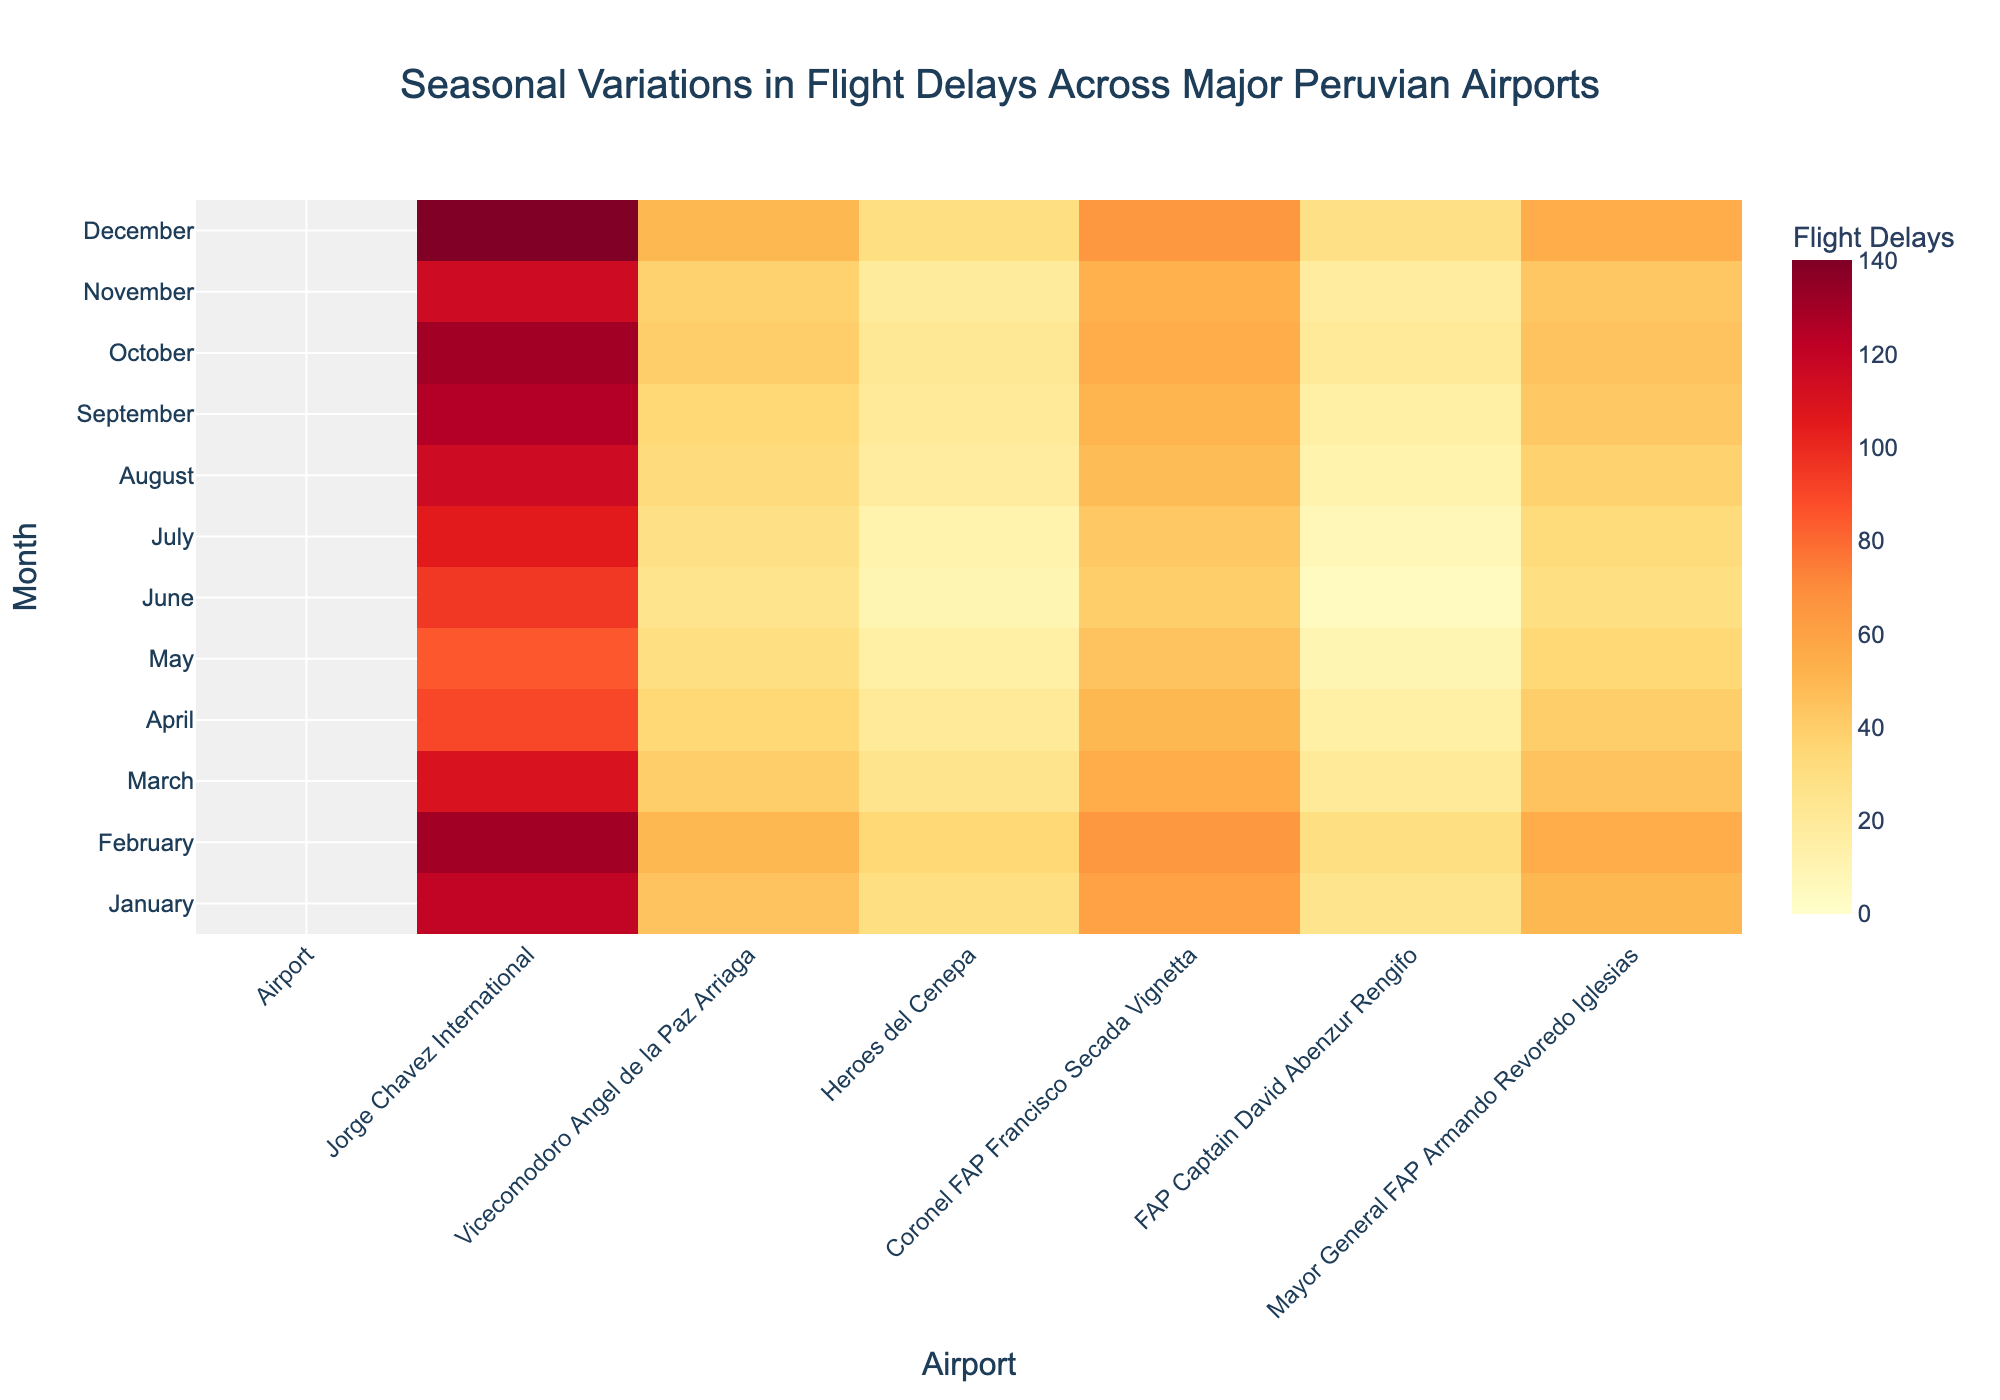What is the title of the heatmap? The title of a heatmap is usually located at the top and provides an overview of the data being visualized. Look for the largest and boldest text.
Answer: Seasonal Variations in Flight Delays Across Major Peruvian Airports Which month has the highest number of flight delays at Jorge Chavez International Airport? To find out which month has the highest number of flight delays, locate Jorge Chavez International Airport column and look for the darkest color (indicating the highest value).
Answer: December What is the color associated with the maximum number of flight delays? Identify the color at the highest point of the color scale, which usually corresponds to the darkest or most intense shade on the heatmap.
Answer: Dark Red During which month did Coronel FAP Francisco Secada Vignetta have the lowest number of flight delays? Locate the column for Coronel FAP Francisco Secada Vignetta and find the lightest color, which indicates the lowest value.
Answer: June How do flight delays in January compare between Jorge Chavez International and FAP Captain David Abenzur Rengifo? Compare the color intensity for January in the columns for both Jorge Chavez International and FAP Captain David Abenzur Rengifo. The darker the color, the higher the number of delays.
Answer: Jorge Chavez International has more delays What is the average number of flight delays in March across all the airports? To find the average, add up the number of delays for each airport in March and divide by the number of airports. The values are: 110, 40, 25, 55, 20, 45. So, (110 + 40 + 25 + 55 + 20 + 45) / 6 = 295 / 6.
Answer: 49.17 Which airport showed the most variability in flight delays across the year? Look for the airport with the widest range of colors from lightest to darkest, indicating high variability. This can be determined by comparing the extremes of color shades in each airport's column.
Answer: Jorge Chavez International What seasonal trend can you observe for flight delays at Vicecomodoro Angel de la Paz Arriaga? Look at the pattern of colors over the months for this airport. If the colors gradually change from light to dark or vice versa, this indicates a seasonal trend.
Answer: Increasing delays towards December How do flight delays in July compare between Mayor General FAP Armando Revoredo Iglesias and Heroes del Cenepa? Compare the color intensity for July in the columns for both Mayor General FAP Armando Revoredo Iglesias and Heroes del Cenepa. The darker the color, the higher the number of delays.
Answer: Mayor General FAP Armando Revoredo Iglesias has more delays Which month overall had the lowest flight delays across all airports? Find the row where the majority of cells have the lightest colors, indicating the lowest delays.
Answer: May 